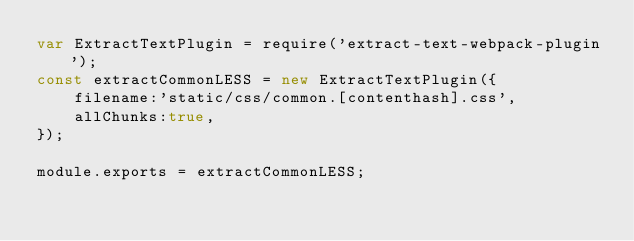<code> <loc_0><loc_0><loc_500><loc_500><_JavaScript_>var ExtractTextPlugin = require('extract-text-webpack-plugin');
const extractCommonLESS = new ExtractTextPlugin({
    filename:'static/css/common.[contenthash].css',
    allChunks:true,
});

module.exports = extractCommonLESS;</code> 